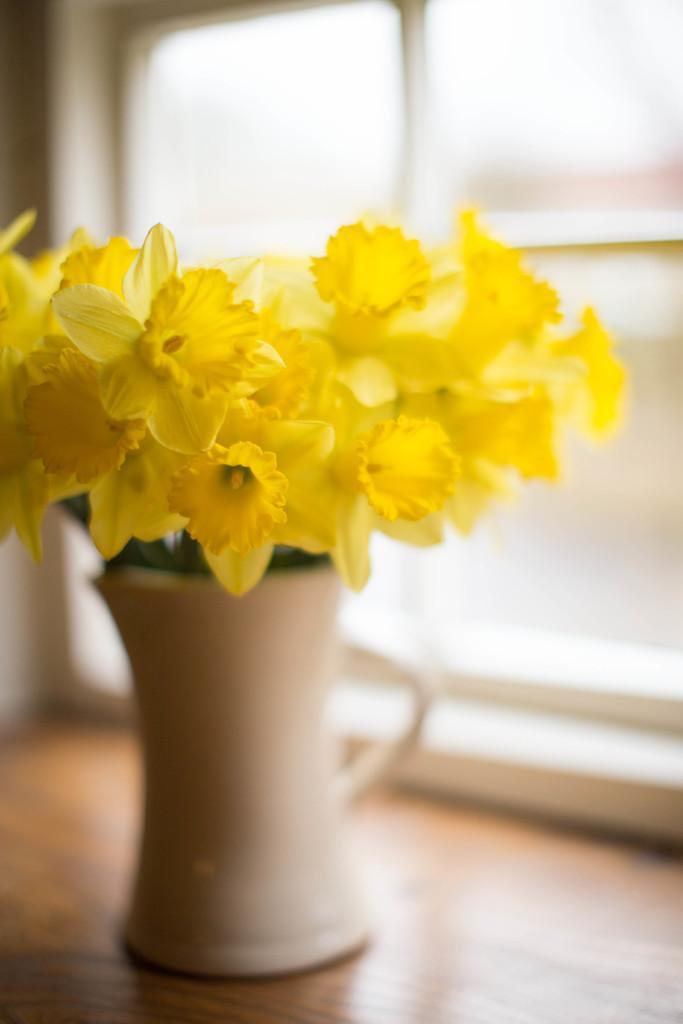Can you describe this image briefly? In this image, I can see a flower vase on a table and a window. This image taken, maybe in a room. 